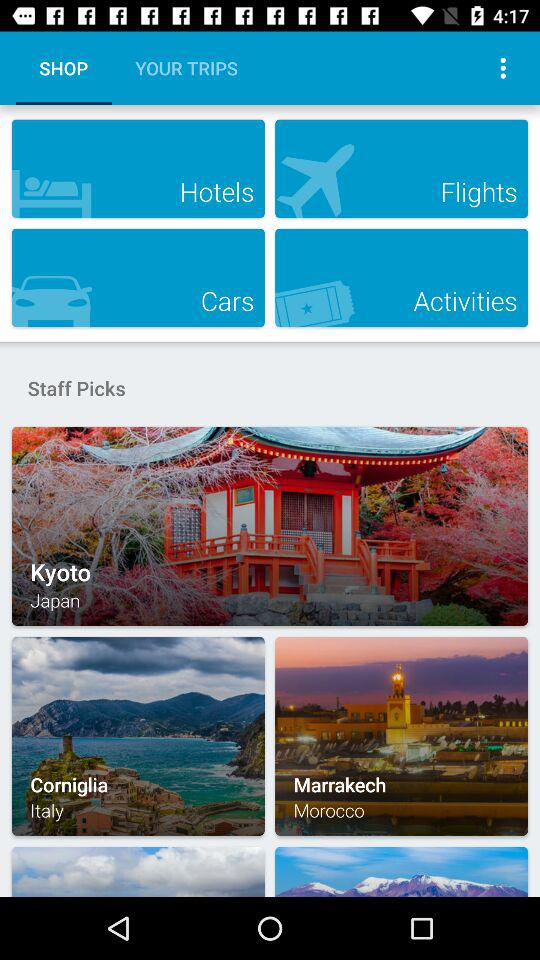Which tab is selected? The selected tab is "SHOP". 